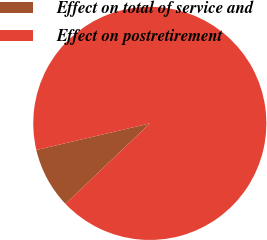Convert chart to OTSL. <chart><loc_0><loc_0><loc_500><loc_500><pie_chart><fcel>Effect on total of service and<fcel>Effect on postretirement<nl><fcel>8.46%<fcel>91.54%<nl></chart> 